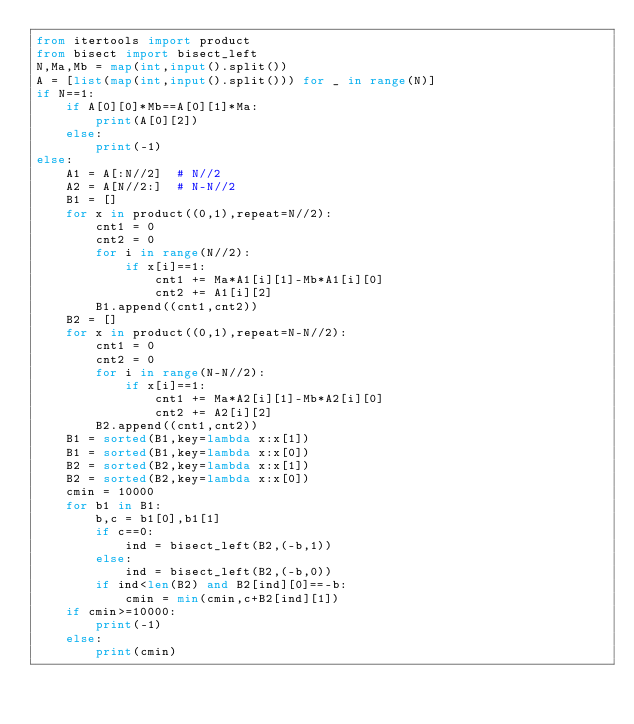Convert code to text. <code><loc_0><loc_0><loc_500><loc_500><_Python_>from itertools import product
from bisect import bisect_left
N,Ma,Mb = map(int,input().split())
A = [list(map(int,input().split())) for _ in range(N)]
if N==1:
    if A[0][0]*Mb==A[0][1]*Ma:
        print(A[0][2])
    else:
        print(-1)
else:
    A1 = A[:N//2]  # N//2
    A2 = A[N//2:]  # N-N//2
    B1 = []
    for x in product((0,1),repeat=N//2):
        cnt1 = 0
        cnt2 = 0
        for i in range(N//2):
            if x[i]==1:
                cnt1 += Ma*A1[i][1]-Mb*A1[i][0]
                cnt2 += A1[i][2]
        B1.append((cnt1,cnt2))
    B2 = []
    for x in product((0,1),repeat=N-N//2):
        cnt1 = 0
        cnt2 = 0
        for i in range(N-N//2):
            if x[i]==1:
                cnt1 += Ma*A2[i][1]-Mb*A2[i][0]
                cnt2 += A2[i][2]
        B2.append((cnt1,cnt2))
    B1 = sorted(B1,key=lambda x:x[1])
    B1 = sorted(B1,key=lambda x:x[0])
    B2 = sorted(B2,key=lambda x:x[1])
    B2 = sorted(B2,key=lambda x:x[0])
    cmin = 10000
    for b1 in B1:
        b,c = b1[0],b1[1]
        if c==0:
            ind = bisect_left(B2,(-b,1))
        else:
            ind = bisect_left(B2,(-b,0))
        if ind<len(B2) and B2[ind][0]==-b:
            cmin = min(cmin,c+B2[ind][1])
    if cmin>=10000:
        print(-1)
    else:
        print(cmin)</code> 